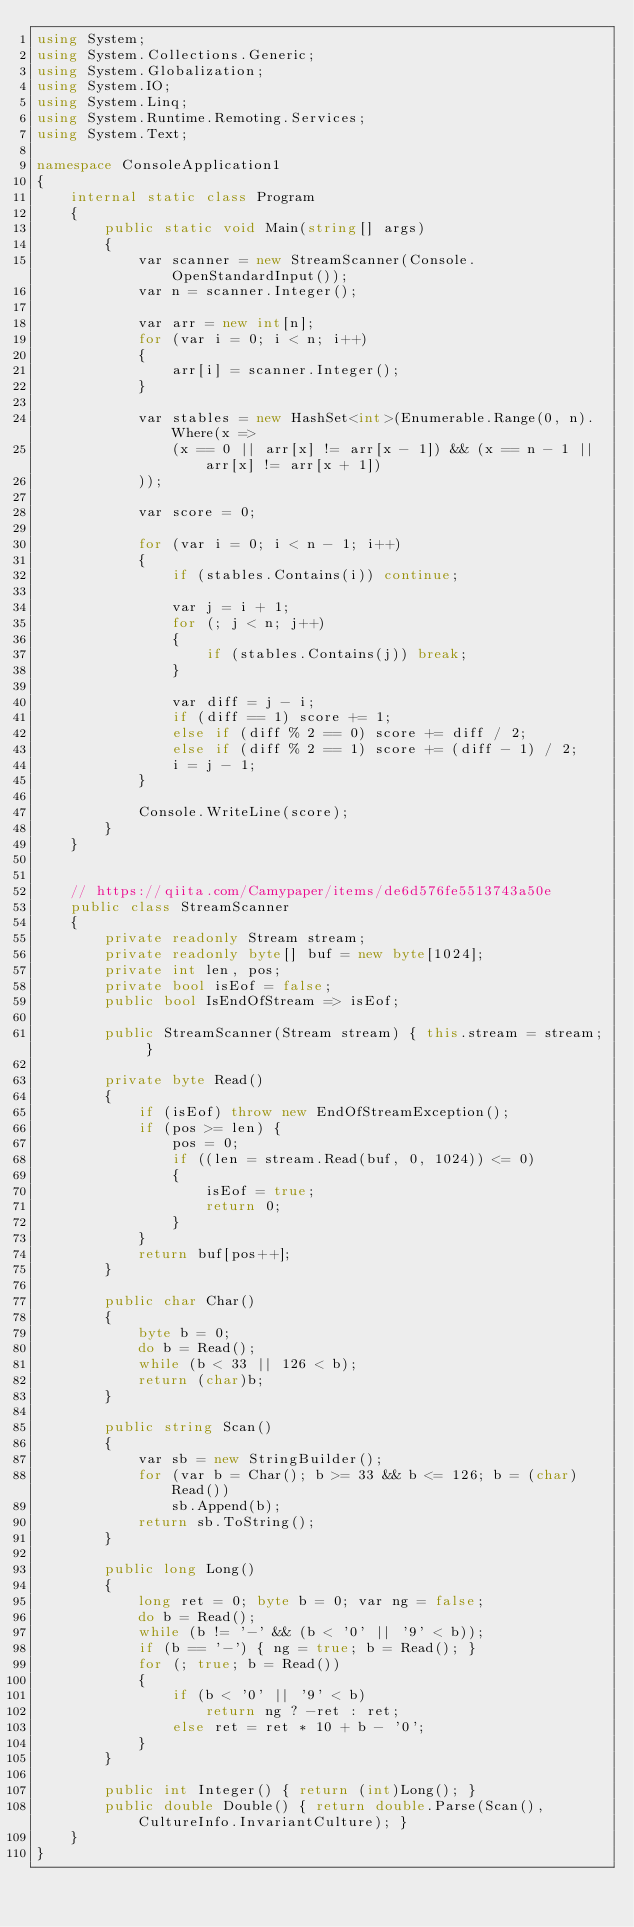<code> <loc_0><loc_0><loc_500><loc_500><_C#_>using System;
using System.Collections.Generic;
using System.Globalization;
using System.IO;
using System.Linq;
using System.Runtime.Remoting.Services;
using System.Text;

namespace ConsoleApplication1
{
    internal static class Program
    {
        public static void Main(string[] args)
        {
            var scanner = new StreamScanner(Console.OpenStandardInput());
            var n = scanner.Integer();
         
            var arr = new int[n];
            for (var i = 0; i < n; i++)
            {
                arr[i] = scanner.Integer();
            }

            var stables = new HashSet<int>(Enumerable.Range(0, n).Where(x =>
                (x == 0 || arr[x] != arr[x - 1]) && (x == n - 1 || arr[x] != arr[x + 1])
            ));

            var score = 0;

            for (var i = 0; i < n - 1; i++)
            {
                if (stables.Contains(i)) continue;

                var j = i + 1;
                for (; j < n; j++)
                {
                    if (stables.Contains(j)) break;
                }

                var diff = j - i;
                if (diff == 1) score += 1;
                else if (diff % 2 == 0) score += diff / 2;
                else if (diff % 2 == 1) score += (diff - 1) / 2;
                i = j - 1;
            }

            Console.WriteLine(score);
        }
    }
    
    
    // https://qiita.com/Camypaper/items/de6d576fe5513743a50e
    public class StreamScanner
    {   
        private readonly Stream stream;
        private readonly byte[] buf = new byte[1024];
        private int len, pos;
        private bool isEof = false;
        public bool IsEndOfStream => isEof;

        public StreamScanner(Stream stream) { this.stream = stream; }
        
        private byte Read()
        {
            if (isEof) throw new EndOfStreamException();
            if (pos >= len) {
                pos = 0;
                if ((len = stream.Read(buf, 0, 1024)) <= 0)
                {
                    isEof = true;
                    return 0;
                }
            }
            return buf[pos++];
        }
        
        public char Char() 
        {
            byte b = 0;
            do b = Read();
            while (b < 33 || 126 < b);
            return (char)b; 
        }
        
        public string Scan()
        {
            var sb = new StringBuilder();
            for (var b = Char(); b >= 33 && b <= 126; b = (char)Read())
                sb.Append(b);
            return sb.ToString();
        }
        
        public long Long()
        {
            long ret = 0; byte b = 0; var ng = false;
            do b = Read();
            while (b != '-' && (b < '0' || '9' < b));
            if (b == '-') { ng = true; b = Read(); }
            for (; true; b = Read())
            {
                if (b < '0' || '9' < b)
                    return ng ? -ret : ret;
                else ret = ret * 10 + b - '0';
            }
        }
        
        public int Integer() { return (int)Long(); }
        public double Double() { return double.Parse(Scan(), CultureInfo.InvariantCulture); }
    }
}
</code> 